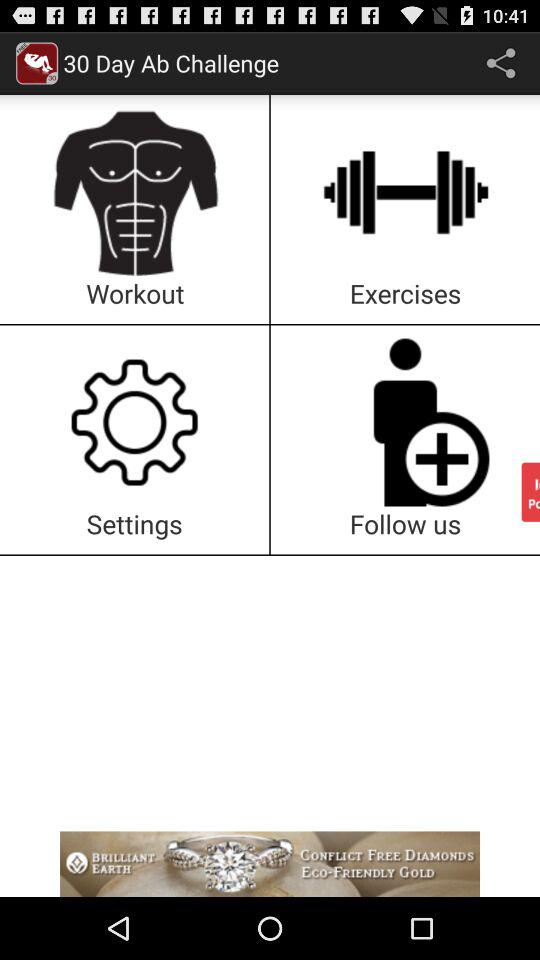Which exercises are available?
When the provided information is insufficient, respond with <no answer>. <no answer> 